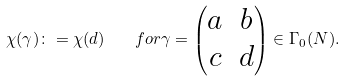<formula> <loc_0><loc_0><loc_500><loc_500>\chi ( \gamma ) \colon = \chi ( d ) \quad f o r \gamma = \begin{pmatrix} a & b \\ c & d \end{pmatrix} \in \Gamma _ { 0 } ( N ) .</formula> 